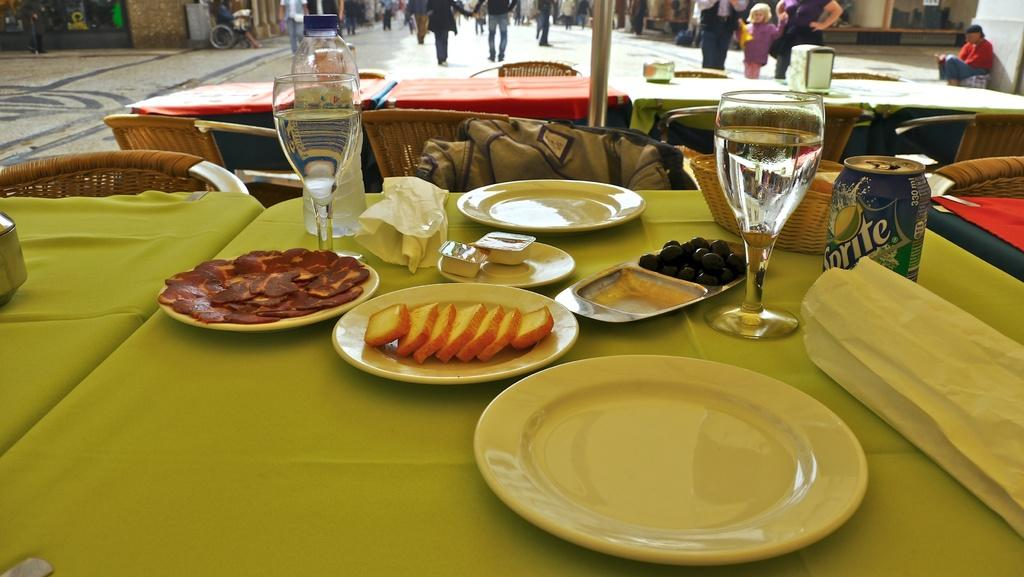What type of furniture can be seen in the image? There are chairs and tables in the image. What type of structures are visible in the image? There are buildings in the image. What are the people in the image doing? There are people walking in the image. What items can be found on the tables in the image? On the tables, there are plates, glasses, a tin, a basket, and food items. Where is the glove located in the image? There is no glove present in the image. What type of basin can be seen in the image? There is no basin present in the image. 